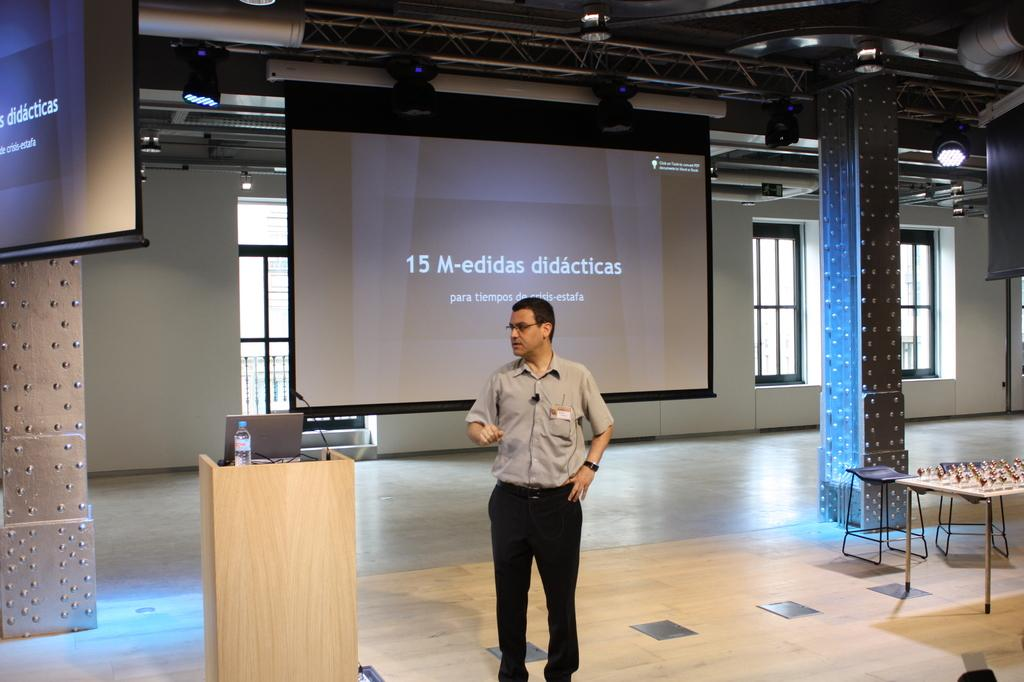<image>
Present a compact description of the photo's key features. A man stands in an empty meeting room with a large screen behind him bears a 15-M announcement. 